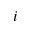<formula> <loc_0><loc_0><loc_500><loc_500>i</formula> 